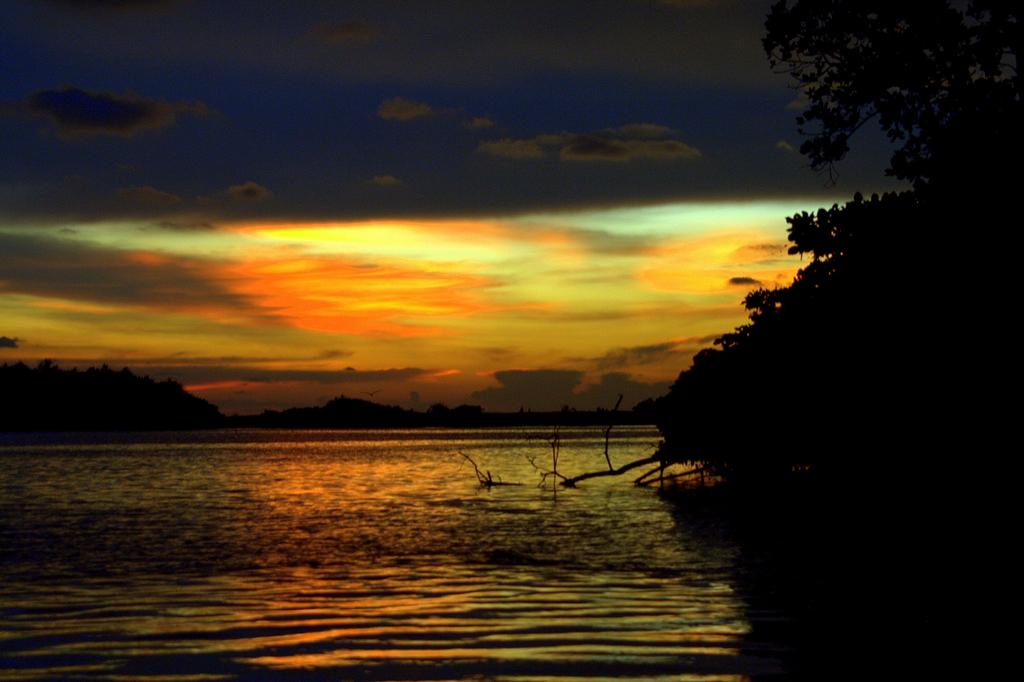What is the primary element visible in the image? There is water in the image. What type of vegetation can be seen on the right side of the image? There is a tree to the right of the image. What is visible in the sky at the top of the image? There are clouds visible in the sky at the top of the image. What type of houses can be seen in the image? There are no houses present in the image; it features water, a tree, and clouds in the sky. What type of structure is depicted in the image? The image does not depict any specific structure; it primarily features water, a tree, and clouds in the sky. 